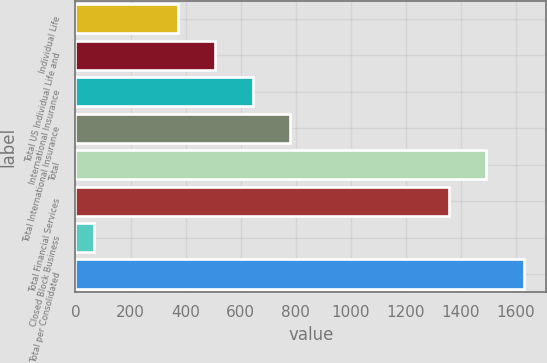<chart> <loc_0><loc_0><loc_500><loc_500><bar_chart><fcel>Individual Life<fcel>Total US Individual Life and<fcel>International Insurance<fcel>Total International Insurance<fcel>Total<fcel>Total Financial Services<fcel>Closed Block Business<fcel>Total per Consolidated<nl><fcel>372<fcel>507.7<fcel>643.4<fcel>779.1<fcel>1492.7<fcel>1357<fcel>67<fcel>1628.4<nl></chart> 